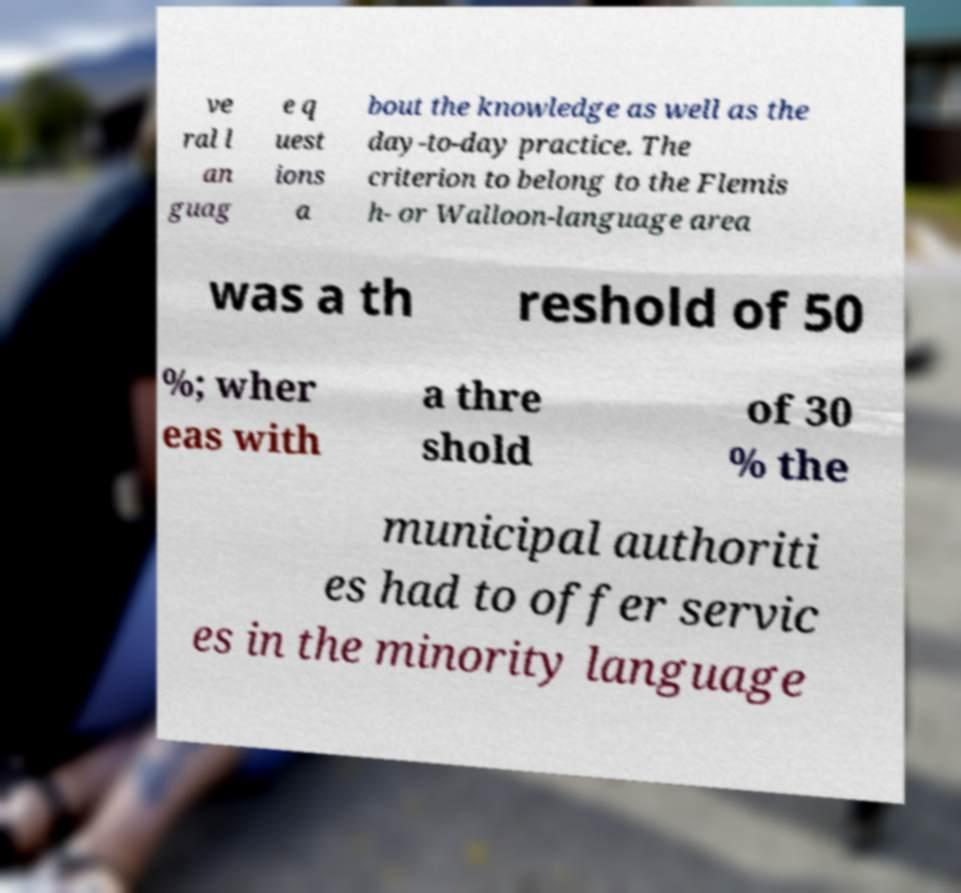Can you accurately transcribe the text from the provided image for me? ve ral l an guag e q uest ions a bout the knowledge as well as the day-to-day practice. The criterion to belong to the Flemis h- or Walloon-language area was a th reshold of 50 %; wher eas with a thre shold of 30 % the municipal authoriti es had to offer servic es in the minority language 